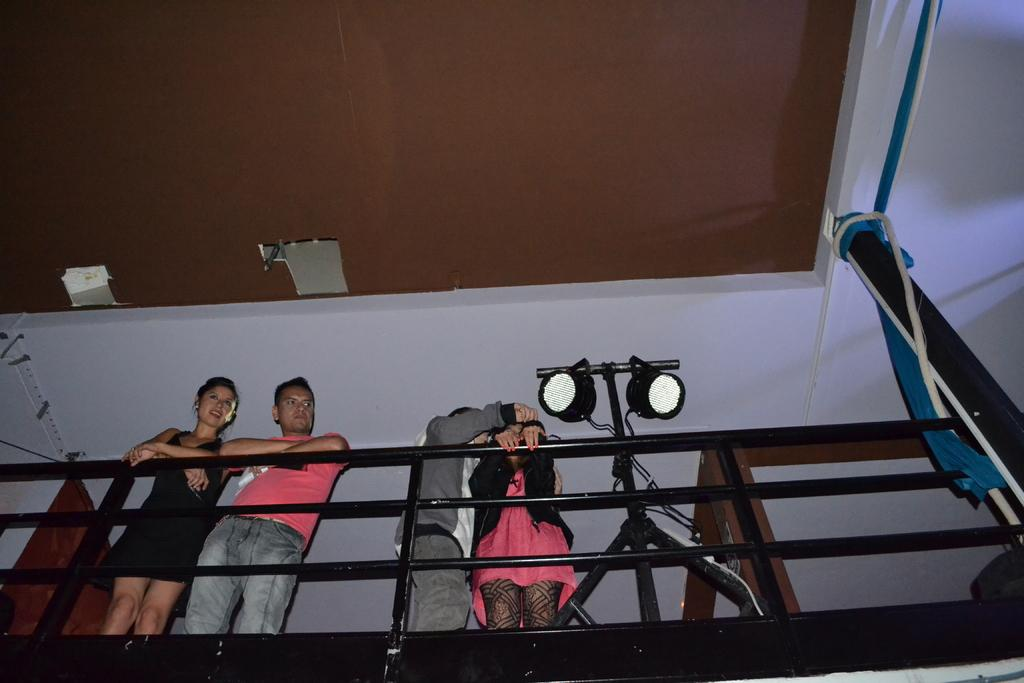What can be observed about the people in the image? There are people standing in the image. What is present near the people in the image? There is railing in the image. What can be seen providing illumination in the image? There are lights visible in the image. What structure is present in the image? There is a stand in the image. What is located on the right side of the image? There are objects visible on the right side of the image. What type of butter is being used to grease the railing in the image? There is no butter present in the image, nor is there any indication that the railing is being greased. 